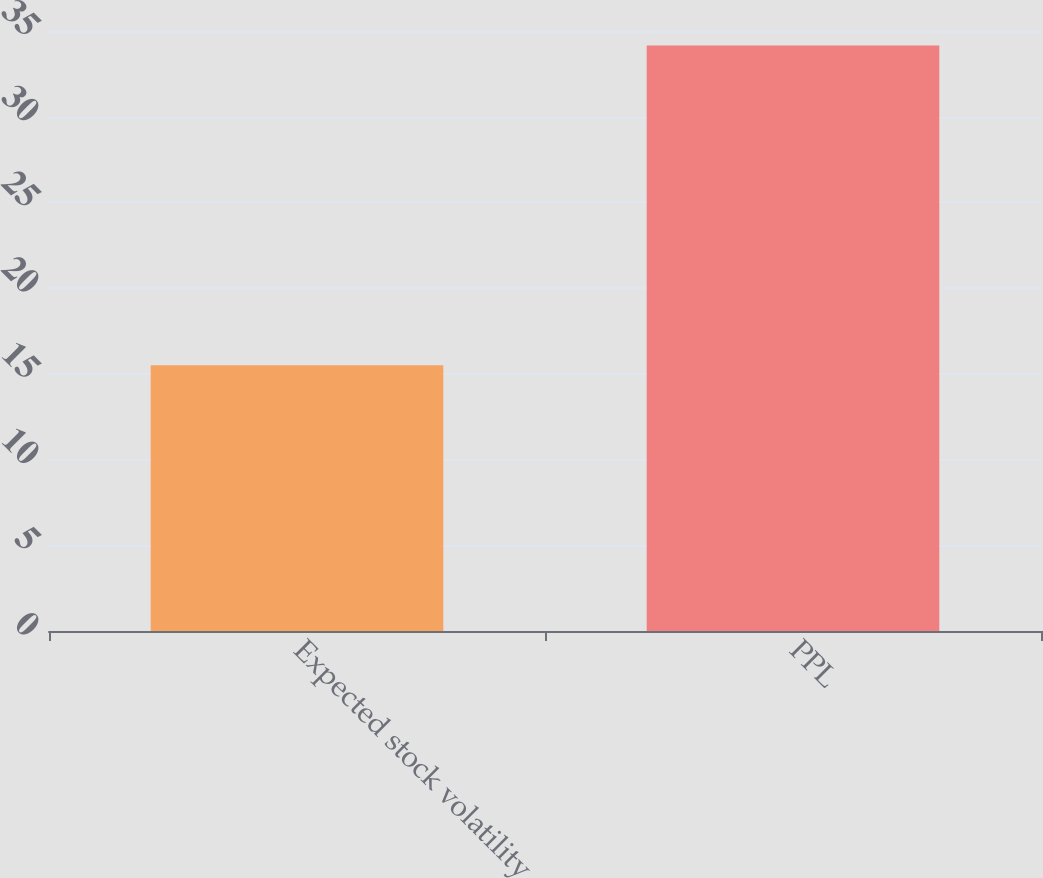Convert chart. <chart><loc_0><loc_0><loc_500><loc_500><bar_chart><fcel>Expected stock volatility<fcel>PPL<nl><fcel>15.5<fcel>34.15<nl></chart> 